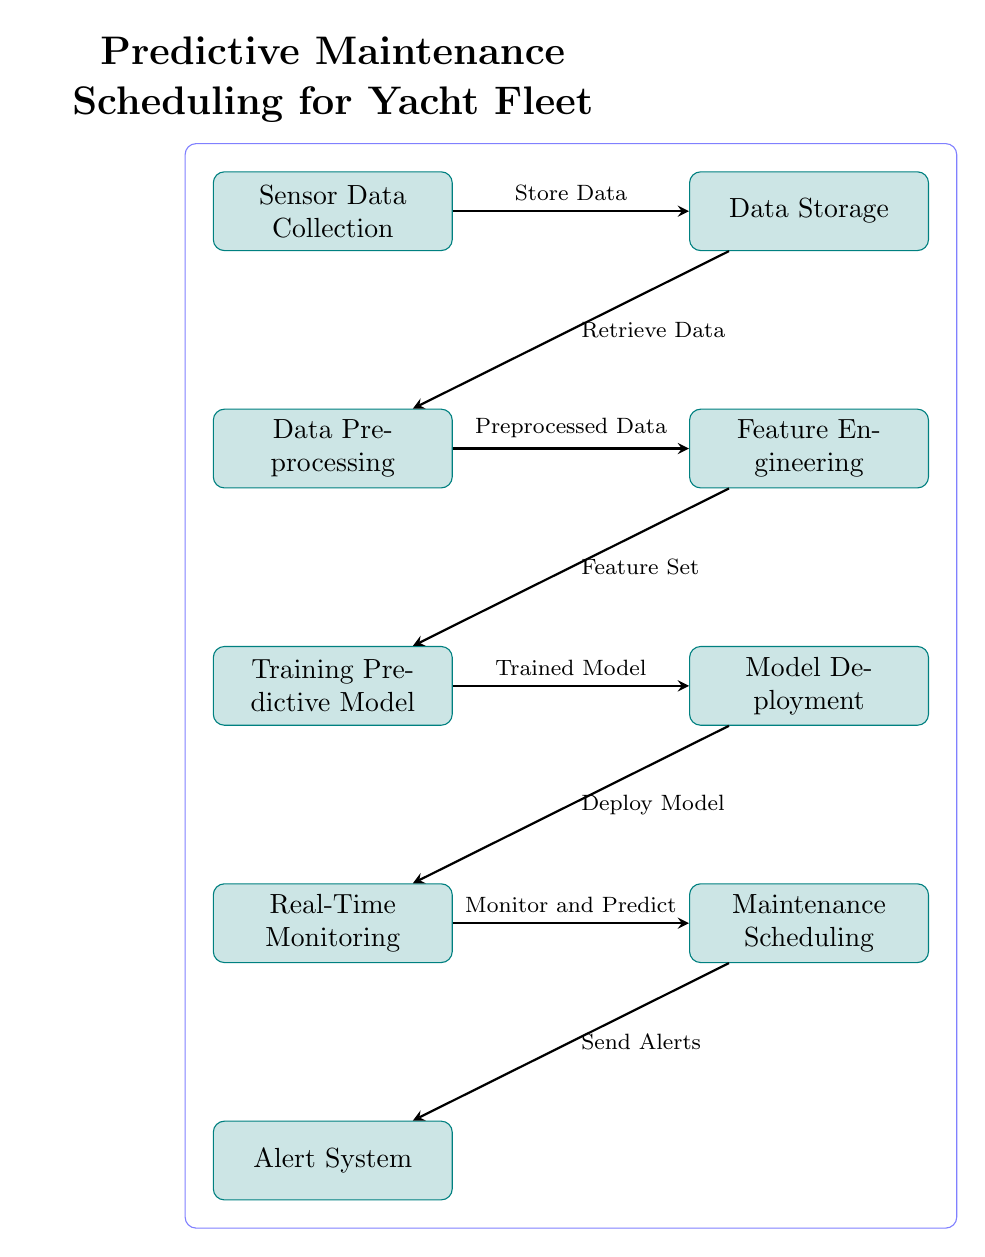What is the first step in the process? The first step in the process is "Sensor Data Collection," which is located at the top left of the diagram.
Answer: Sensor Data Collection How many nodes are in the diagram? By counting the distinct process nodes in the diagram, there are a total of eight nodes.
Answer: 8 What flows from the "Data Preprocessing" node? The "Data Preprocessing" node flows to the "Feature Engineering" node, which represents the next step in the process.
Answer: Feature Engineering What is sent after "Maintenance Scheduling"? According to the diagram, the action that follows "Maintenance Scheduling" is the "Send Alerts" process, indicating communication of the maintenance status.
Answer: Send Alerts What does the "Model Deployment" node receive? The "Model Deployment" node receives the "Trained Model" from the "Training Predictive Model" node, indicating completion of model training.
Answer: Trained Model What step comes before "Real-Time Monitoring"? The "Model Deployment" step occurs immediately before "Real-Time Monitoring," indicating that the model must be deployed for monitoring to take place.
Answer: Model Deployment Which two processes are directly connected? "Data Storage" is directly connected to "Data Preprocessing," as indicated by the arrow flowing from one to the other.
Answer: Data Storage and Data Preprocessing In what order are the predictive model steps executed? The order of the steps for the predictive model is "Training Predictive Model" followed by "Model Deployment" and then "Real-Time Monitoring," indicating a sequential execution.
Answer: Training Predictive Model, Model Deployment, Real-Time Monitoring What is the last step in the diagram? The final step in the diagram is the "Alert System," representing the end of the predictive maintenance process.
Answer: Alert System 